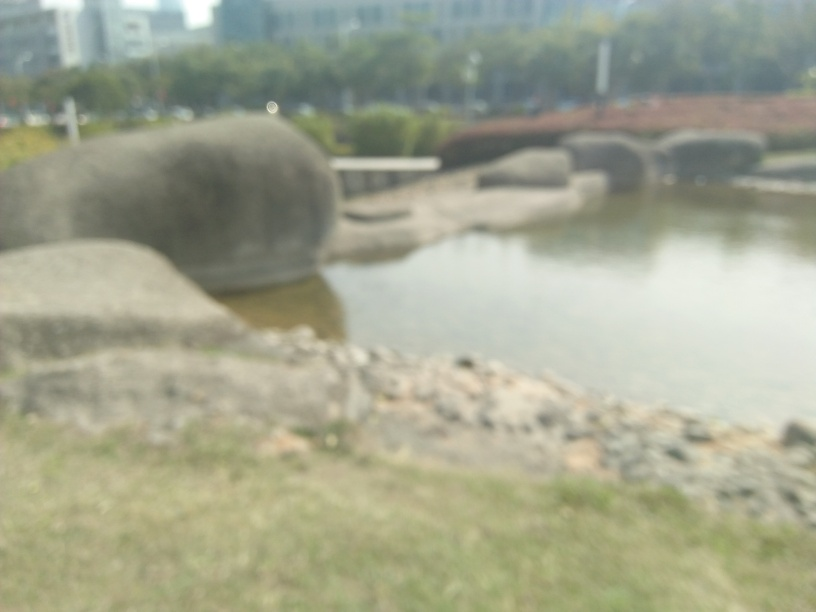Is the overall quality of the image good?
A. Yes
B. No
Answer with the option's letter from the given choices directly.
 B. 